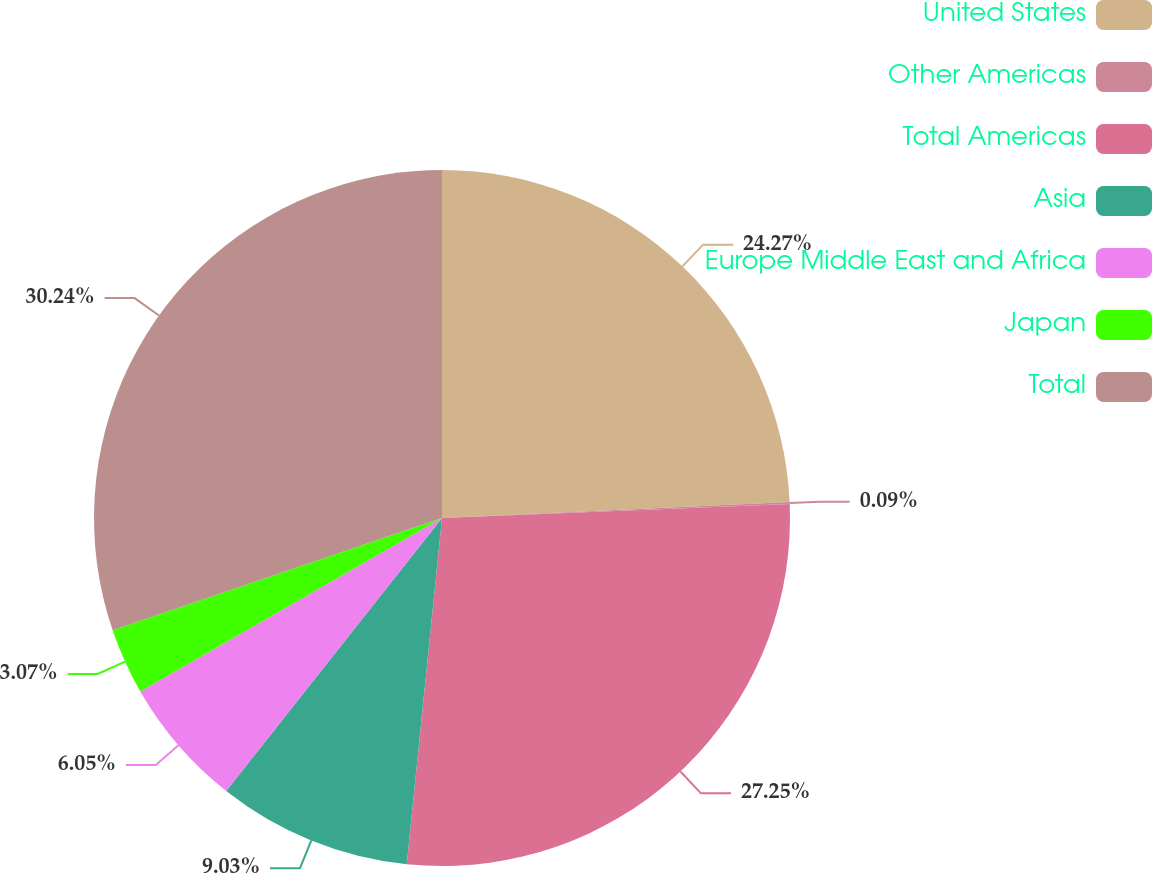<chart> <loc_0><loc_0><loc_500><loc_500><pie_chart><fcel>United States<fcel>Other Americas<fcel>Total Americas<fcel>Asia<fcel>Europe Middle East and Africa<fcel>Japan<fcel>Total<nl><fcel>24.27%<fcel>0.09%<fcel>27.25%<fcel>9.03%<fcel>6.05%<fcel>3.07%<fcel>30.23%<nl></chart> 